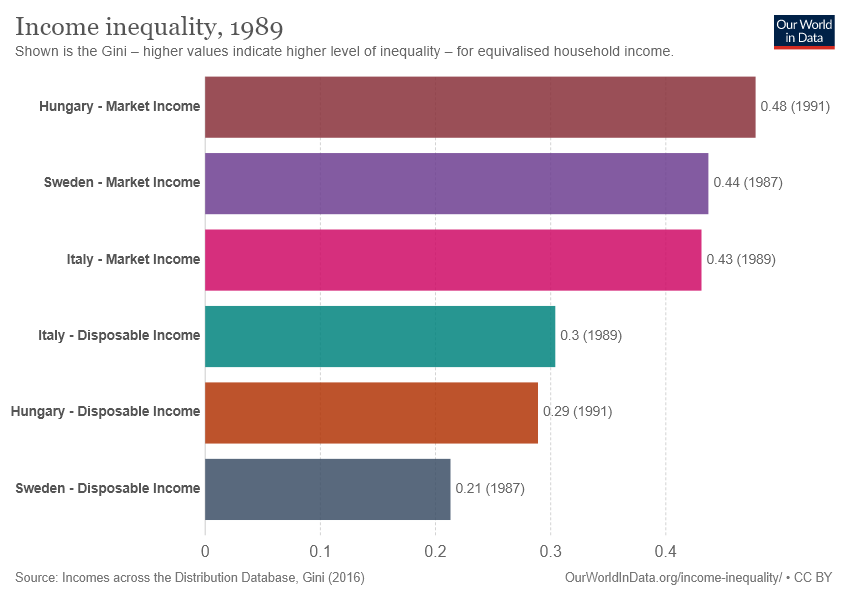Point out several critical features in this image. The sum of Green and Grey bars is 0.6. The year mentioned in the description is 1989. 